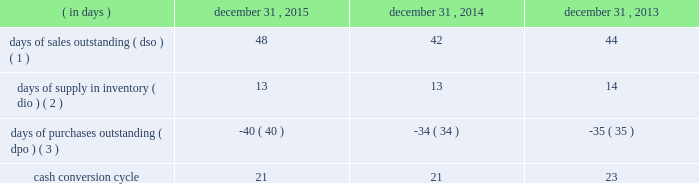Table of contents ( 4 ) the decline in cash flows was driven by the timing of inventory purchases at the end of 2014 versus 2013 .
In order to manage our working capital and operating cash needs , we monitor our cash conversion cycle , defined as days of sales outstanding in accounts receivable plus days of supply in inventory minus days of purchases outstanding in accounts payable , based on a rolling three-month average .
Components of our cash conversion cycle are as follows: .
( 1 ) represents the rolling three-month average of the balance of trade accounts receivable , net at the end of the period divided by average daily net sales for the same three-month period .
Also incorporates components of other miscellaneous receivables .
( 2 ) represents the rolling three-month average of the balance of merchandise inventory at the end of the period divided by average daily cost of goods sold for the same three-month period .
( 3 ) represents the rolling three-month average of the combined balance of accounts payable-trade , excluding cash overdrafts , and accounts payable-inventory financing at the end of the period divided by average daily cost of goods sold for the same three-month period .
The cash conversion cycle remained at 21 days at december 31 , 2015 and december 31 , 2014 .
The increase in dso was primarily driven by a higher accounts receivable balance at december 31 , 2015 driven by higher public segment sales where customers generally take longer to pay than customers in our corporate segment , slower government payments in certain states due to budget issues and an increase in net sales and related accounts receivable for third-party services such as software assurance and warranties .
These services have an unfavorable impact on dso as the receivable is recognized on the balance sheet on a gross basis while the corresponding sales amount in the statement of operations is recorded on a net basis .
These services have a favorable impact on dpo as the payable is recognized on the balance sheet without a corresponding cost of sale in the statement of operations because the cost paid to the vendor or third-party service provider is recorded as a reduction to net sales .
In addition to the impact of these services on dpo , dpo also increased due to the mix of payables with certain vendors that have longer payment terms .
The cash conversion cycle decreased to 21 days at december 31 , 2014 compared to 23 days at december 31 , 2013 , primarily driven by improvement in dso .
The decline in dso was primarily driven by improved collections and early payments from certain customers .
Additionally , the timing of inventory receipts at the end of 2014 had a favorable impact on dio and an unfavorable impact on dpo .
Investing activities net cash used in investing activities increased $ 189.6 million in 2015 compared to 2014 .
The increase was primarily due to the completion of the acquisition of kelway by purchasing the remaining 65% ( 65 % ) of its outstanding common stock on august 1 , 2015 .
Additionally , capital expenditures increased $ 35.1 million to $ 90.1 million from $ 55.0 million for 2015 and 2014 , respectively , primarily for our new office location and an increase in spending related to improvements to our information technology systems .
Net cash used in investing activities increased $ 117.7 million in 2014 compared to 2013 .
We paid $ 86.8 million in the fourth quarter of 2014 to acquire a 35% ( 35 % ) non-controlling interest in kelway .
Additionally , capital expenditures increased $ 7.9 million to $ 55.0 million from $ 47.1 million in 2014 and 2013 , respectively , primarily for improvements to our information technology systems during both years .
Financing activities net cash used in financing activities increased $ 114.5 million in 2015 compared to 2014 .
The increase was primarily driven by share repurchases during the year ended december 31 , 2015 which resulted in an increase in cash used for financing activities of $ 241.3 million .
For more information on our share repurchase program , see item 5 , 201cmarket for registrant 2019s common equity , related stockholder matters and issuer purchases of equity securities . 201d the increase was partially offset by the changes in accounts payable-inventory financing , which resulted in an increase in cash provided for financing activities of $ 20.4 million , and the net impact of our debt transactions which resulted in cash outflows of $ 7.1 million and $ 145.9 million during the years .
What was the percent of the change in days of sales outstanding from 2014 to 2015? 
Computations: ((48 - 42) / 42)
Answer: 0.14286. 